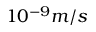<formula> <loc_0><loc_0><loc_500><loc_500>1 0 ^ { - 9 } m / s</formula> 